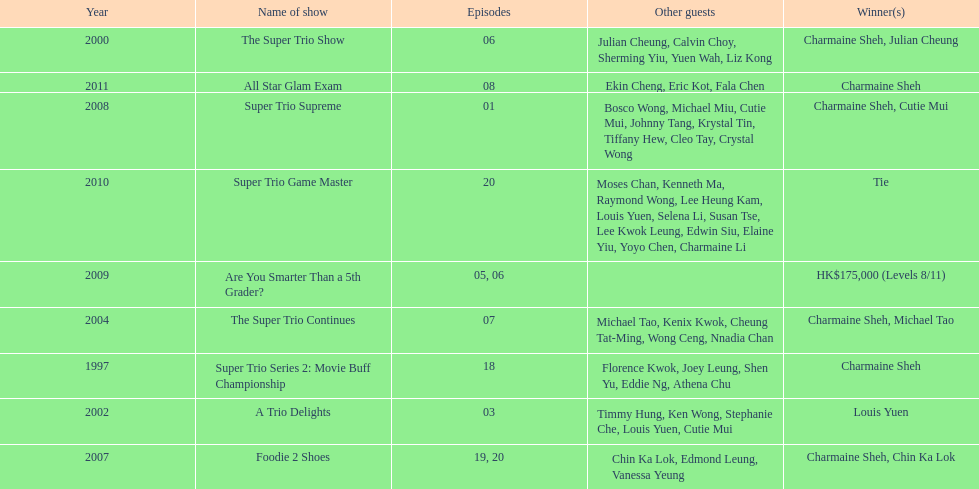How many times has charmaine sheh emerged as a winner on a variety show? 6. 